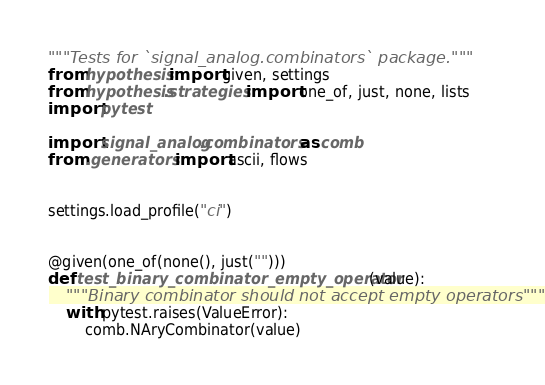Convert code to text. <code><loc_0><loc_0><loc_500><loc_500><_Python_>"""Tests for `signal_analog.combinators` package."""
from hypothesis import given, settings
from hypothesis.strategies import one_of, just, none, lists
import pytest

import signal_analog.combinators as comb
from .generators import ascii, flows


settings.load_profile("ci")


@given(one_of(none(), just("")))
def test_binary_combinator_empty_operator(value):
    """Binary combinator should not accept empty operators"""
    with pytest.raises(ValueError):
        comb.NAryCombinator(value)

</code> 